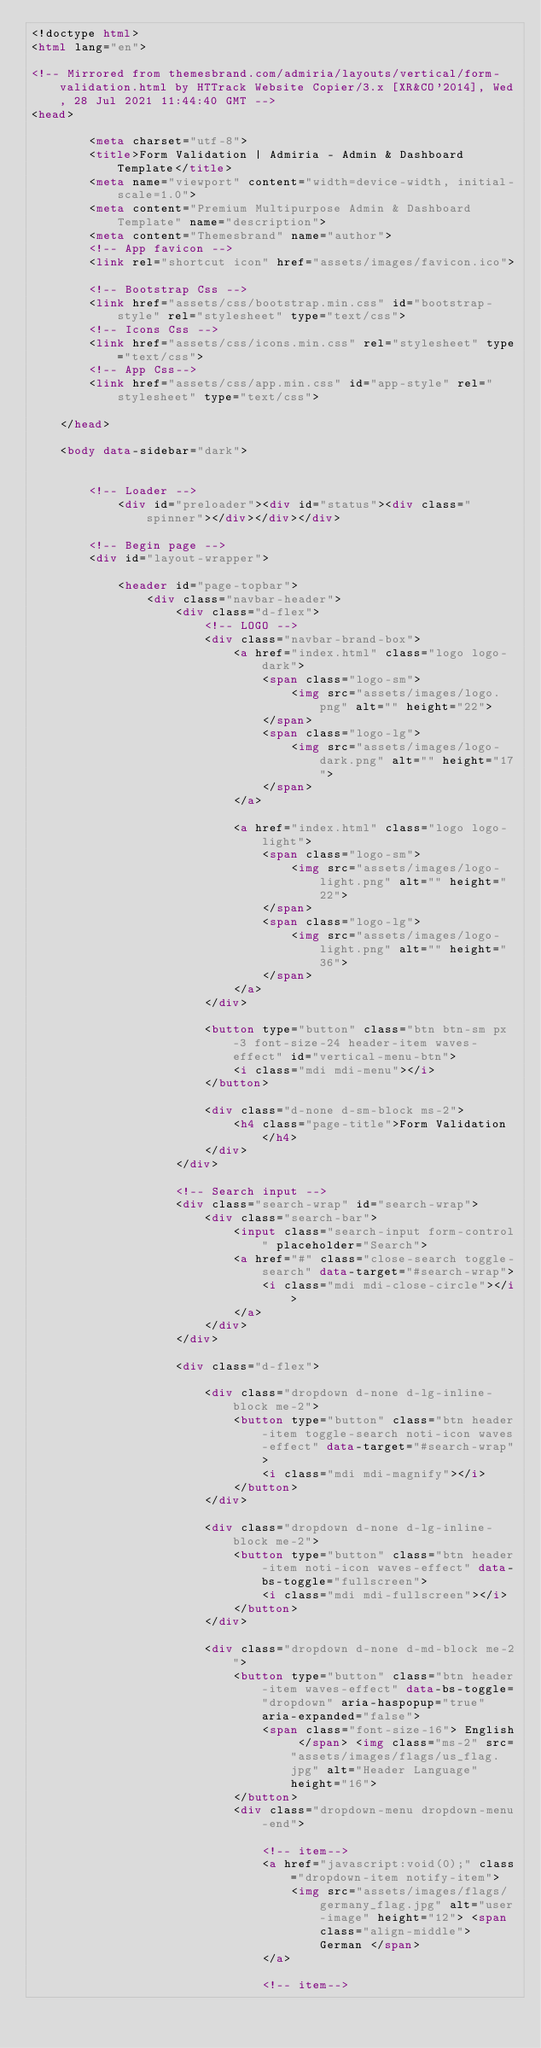Convert code to text. <code><loc_0><loc_0><loc_500><loc_500><_HTML_><!doctype html>
<html lang="en">
    
<!-- Mirrored from themesbrand.com/admiria/layouts/vertical/form-validation.html by HTTrack Website Copier/3.x [XR&CO'2014], Wed, 28 Jul 2021 11:44:40 GMT -->
<head>
    
        <meta charset="utf-8">
        <title>Form Validation | Admiria - Admin & Dashboard Template</title>
        <meta name="viewport" content="width=device-width, initial-scale=1.0">
        <meta content="Premium Multipurpose Admin & Dashboard Template" name="description">
        <meta content="Themesbrand" name="author">
        <!-- App favicon -->
        <link rel="shortcut icon" href="assets/images/favicon.ico">
    
        <!-- Bootstrap Css -->
        <link href="assets/css/bootstrap.min.css" id="bootstrap-style" rel="stylesheet" type="text/css">
        <!-- Icons Css -->
        <link href="assets/css/icons.min.css" rel="stylesheet" type="text/css">
        <!-- App Css-->
        <link href="assets/css/app.min.css" id="app-style" rel="stylesheet" type="text/css">
    
    </head>

    <body data-sidebar="dark">


        <!-- Loader -->
            <div id="preloader"><div id="status"><div class="spinner"></div></div></div>

        <!-- Begin page -->
        <div id="layout-wrapper">

            <header id="page-topbar">
                <div class="navbar-header">
                    <div class="d-flex">
                        <!-- LOGO -->
                        <div class="navbar-brand-box">
                            <a href="index.html" class="logo logo-dark">
                                <span class="logo-sm">
                                    <img src="assets/images/logo.png" alt="" height="22">
                                </span>
                                <span class="logo-lg">
                                    <img src="assets/images/logo-dark.png" alt="" height="17">
                                </span>
                            </a>

                            <a href="index.html" class="logo logo-light">
                                <span class="logo-sm">
                                    <img src="assets/images/logo-light.png" alt="" height="22">
                                </span>
                                <span class="logo-lg">
                                    <img src="assets/images/logo-light.png" alt="" height="36">
                                </span>
                            </a>
                        </div>

                        <button type="button" class="btn btn-sm px-3 font-size-24 header-item waves-effect" id="vertical-menu-btn">
                            <i class="mdi mdi-menu"></i>
                        </button>

                        <div class="d-none d-sm-block ms-2">
                            <h4 class="page-title">Form Validation</h4>
                        </div>
                    </div>

                    <!-- Search input -->
                    <div class="search-wrap" id="search-wrap">
                        <div class="search-bar">
                            <input class="search-input form-control" placeholder="Search">
                            <a href="#" class="close-search toggle-search" data-target="#search-wrap">
                                <i class="mdi mdi-close-circle"></i>
                            </a>
                        </div>
                    </div>

                    <div class="d-flex">

                        <div class="dropdown d-none d-lg-inline-block me-2">
                            <button type="button" class="btn header-item toggle-search noti-icon waves-effect" data-target="#search-wrap">
                                <i class="mdi mdi-magnify"></i>
                            </button>
                        </div>

                        <div class="dropdown d-none d-lg-inline-block me-2">
                            <button type="button" class="btn header-item noti-icon waves-effect" data-bs-toggle="fullscreen">
                                <i class="mdi mdi-fullscreen"></i>
                            </button>
                        </div>

                        <div class="dropdown d-none d-md-block me-2">
                            <button type="button" class="btn header-item waves-effect" data-bs-toggle="dropdown" aria-haspopup="true" aria-expanded="false">
                                <span class="font-size-16"> English </span> <img class="ms-2" src="assets/images/flags/us_flag.jpg" alt="Header Language" height="16">
                            </button>
                            <div class="dropdown-menu dropdown-menu-end">

                                <!-- item-->
                                <a href="javascript:void(0);" class="dropdown-item notify-item">
                                    <img src="assets/images/flags/germany_flag.jpg" alt="user-image" height="12"> <span class="align-middle"> German </span>
                                </a>

                                <!-- item--></code> 